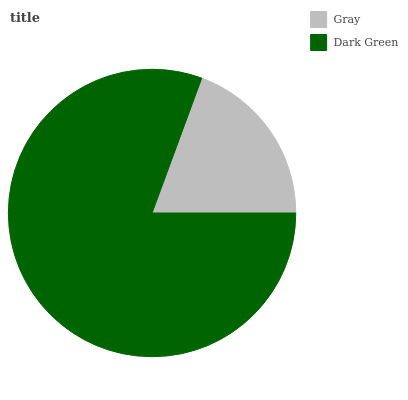Is Gray the minimum?
Answer yes or no. Yes. Is Dark Green the maximum?
Answer yes or no. Yes. Is Dark Green the minimum?
Answer yes or no. No. Is Dark Green greater than Gray?
Answer yes or no. Yes. Is Gray less than Dark Green?
Answer yes or no. Yes. Is Gray greater than Dark Green?
Answer yes or no. No. Is Dark Green less than Gray?
Answer yes or no. No. Is Dark Green the high median?
Answer yes or no. Yes. Is Gray the low median?
Answer yes or no. Yes. Is Gray the high median?
Answer yes or no. No. Is Dark Green the low median?
Answer yes or no. No. 